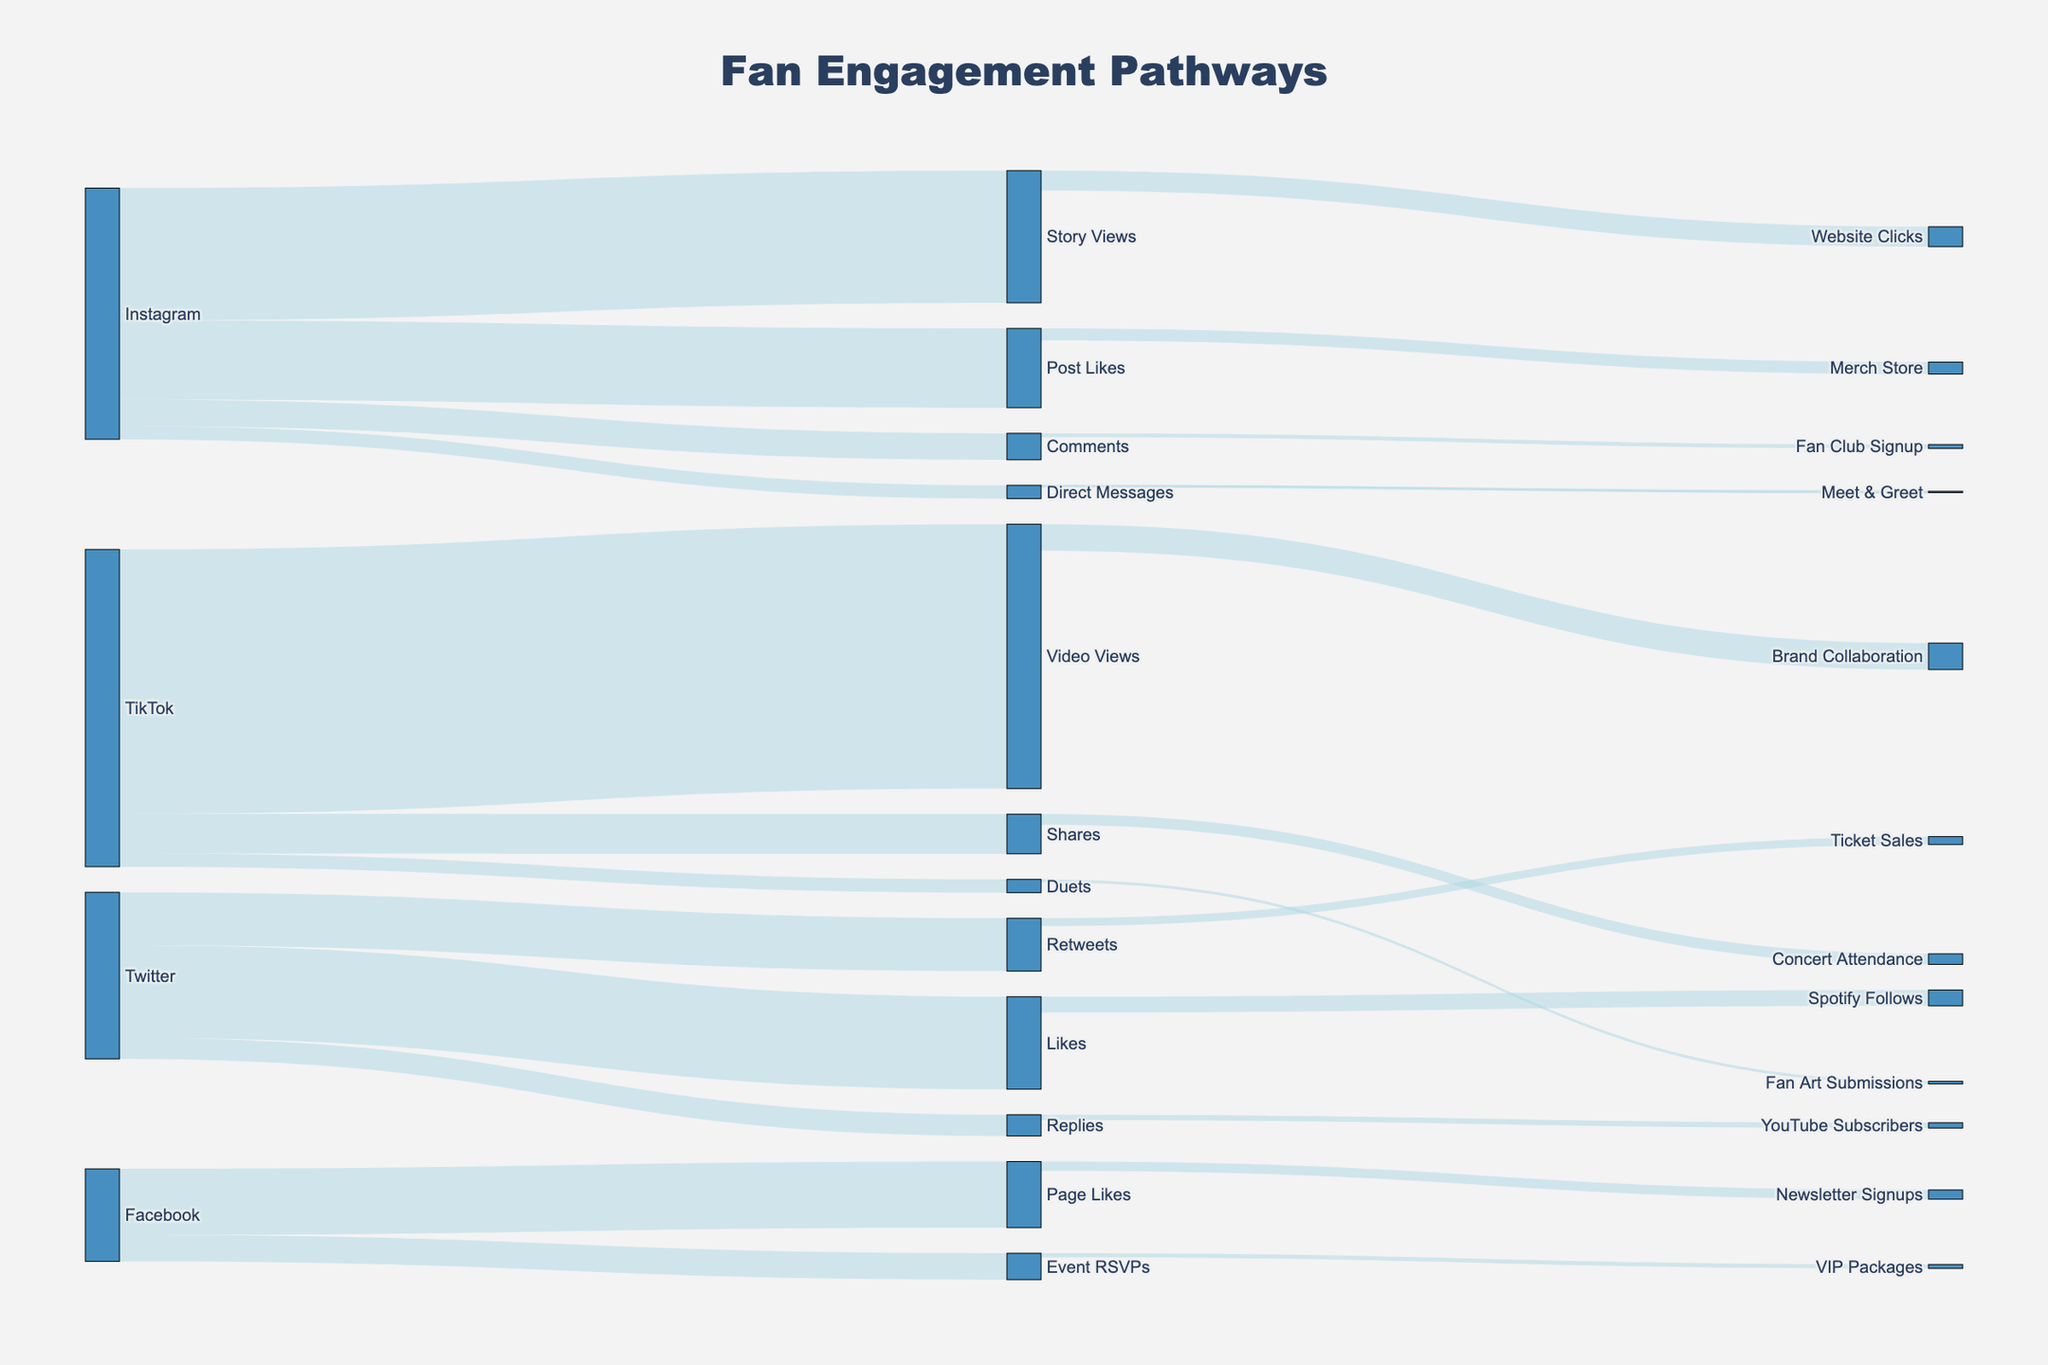Which platform has the highest initial fan engagement through video views? The initial fan engagement through video views is the highest on TikTok. This can be seen from the thickness and length of the flow labeled TikTok to Video Views, showing 1,000,000 engagements.
Answer: TikTok How many fans engaged through post likes on Instagram? The Sankey diagram shows a flow from Instagram to Post Likes, indicating the number of fans who engaged through post likes. The figure specifies that 300,000 fans engaged this way.
Answer: 300,000 Which pathway leads to the most website clicks? The pathways leading to website clicks are through Story Views on Instagram. The diagram shows a flow from Story Views to Website Clicks with 75,000 clicks.
Answer: Instagram Story Views Compare the number of fans who engaged through Instagram comments and Twitter replies. Which platform had more engagement? Looking at the flows from Instagram Comments and Twitter Replies, we see that Instagram Comments had 100,000 engagements, while Twitter Replies had 80,000 engagements. Thus, Instagram Comments had more engagement.
Answer: Instagram Comments How many fans engaged through shares on TikTok? The flow from TikTok to Shares indicates the number of fans who engaged through shares, which amounts to 150,000.
Answer: 150,000 What is the total number of engagements from Facebook? To find the total engagements from Facebook, sum up the values of fans from Page Likes and Event RSVPs. Page Likes have 250,000 and Event RSVPs have 100,000, resulting in a total of 350,000 engagements.
Answer: 350,000 Which pathway leads to more Fan Club Signups: Instagram Comments or TikTok Duets? By comparing the two pathways leading to Fan Club Signups, we see that Instagram Comments have 15,000 signups, and TikTok Duets also have 10,000. Thus, Instagram Comments lead to more Fan Club Signups.
Answer: Instagram Comments What is the total number of fans who engaged through Twitter, combining retweets, likes, and replies? To determine the total engagements through Twitter, sum up the values of fans from Retweets, Likes, and Replies. Retweets have 200,000, Likes have 350,000, and Replies have 80,000. Therefore, the total engagement is 630,000.
Answer: 630,000 What is the relationship between Instagram post likes and merch store visits? The pathway leading from Instagram Post Likes to Merch Store indicates how many fans followed this engagement route. The diagram shows that 45,000 fans engaged through Instagram post likes and resulted in visits to the merch store.
Answer: 45,000 